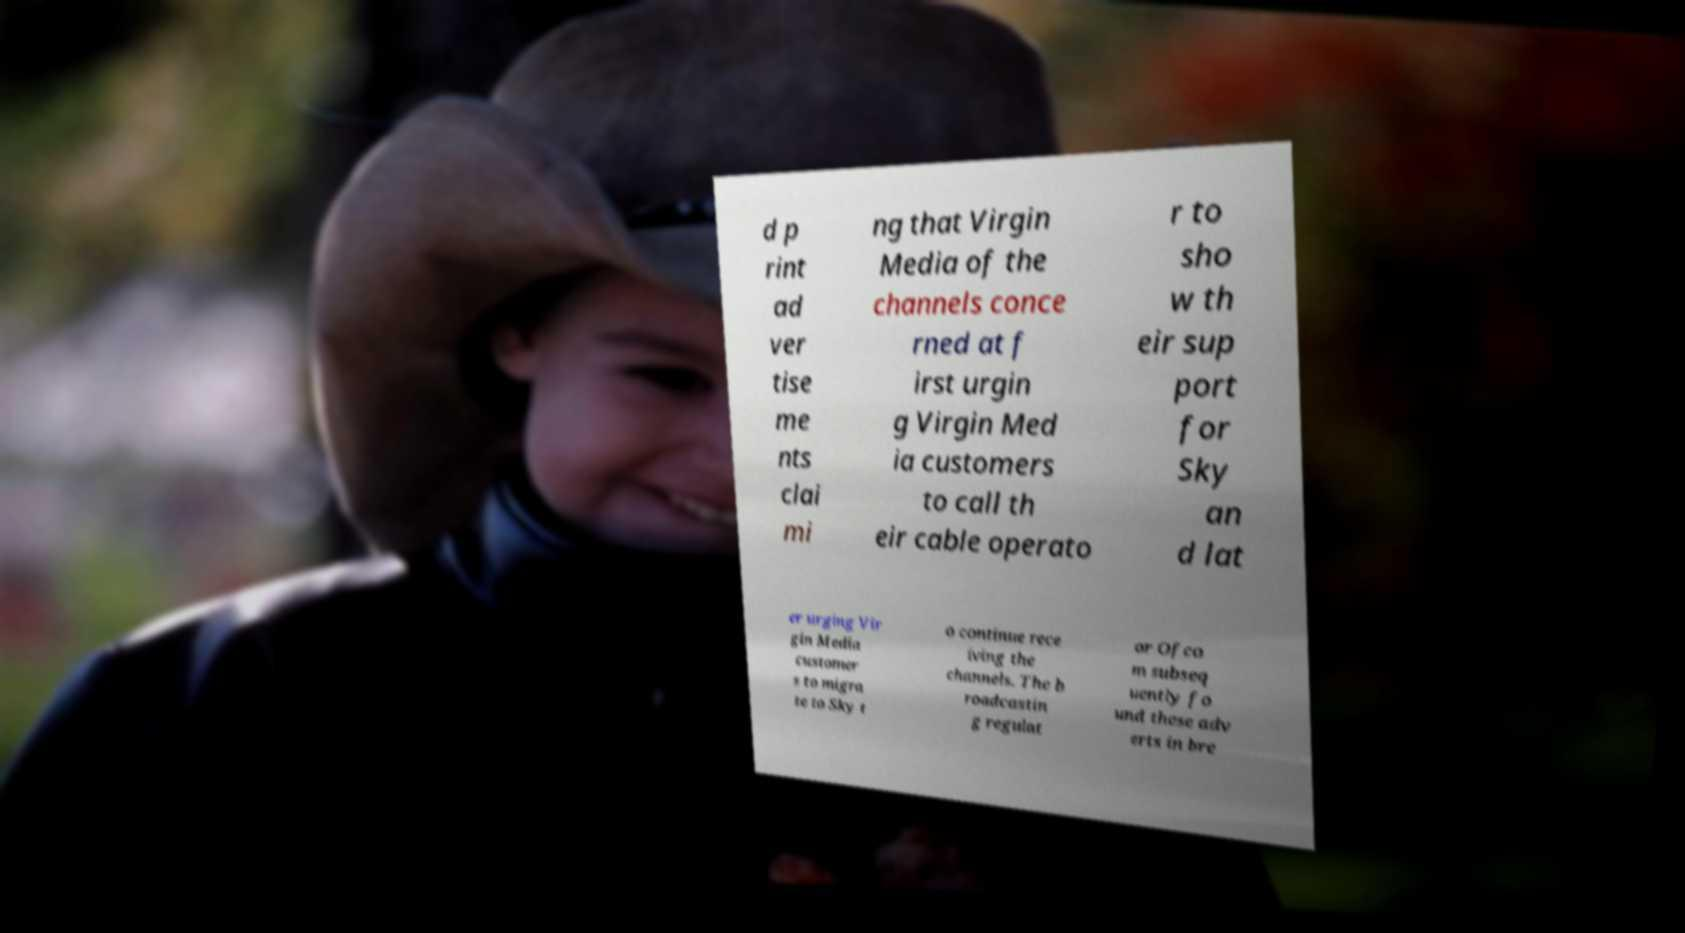There's text embedded in this image that I need extracted. Can you transcribe it verbatim? d p rint ad ver tise me nts clai mi ng that Virgin Media of the channels conce rned at f irst urgin g Virgin Med ia customers to call th eir cable operato r to sho w th eir sup port for Sky an d lat er urging Vir gin Media customer s to migra te to Sky t o continue rece iving the channels. The b roadcastin g regulat or Ofco m subseq uently fo und these adv erts in bre 